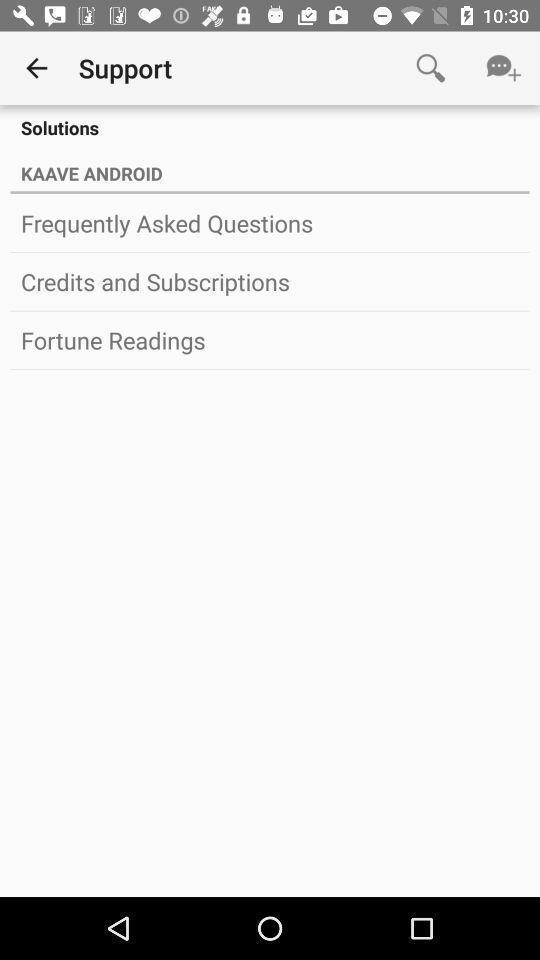What is the overall content of this screenshot? Page showing various support options for an app. 